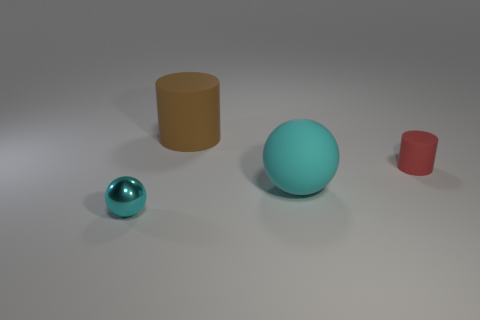Add 1 purple rubber balls. How many objects exist? 5 Add 2 small red rubber spheres. How many small red rubber spheres exist? 2 Subtract 0 gray cylinders. How many objects are left? 4 Subtract all purple matte cubes. Subtract all large brown matte cylinders. How many objects are left? 3 Add 1 red things. How many red things are left? 2 